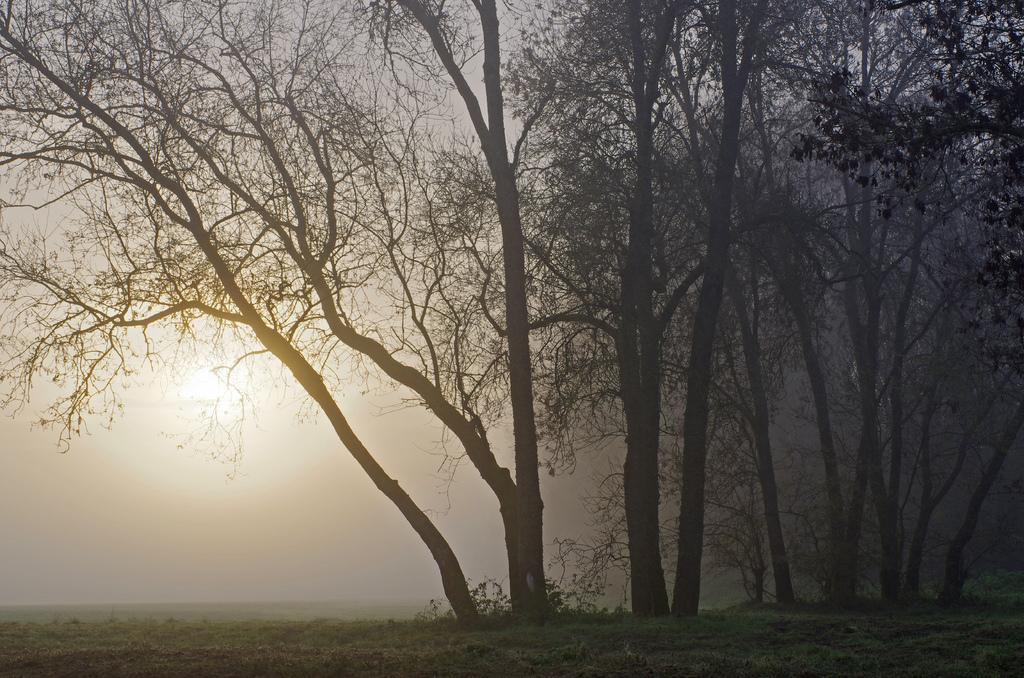Can you describe this image briefly? In this image I can see the ground, some grass on the ground, few trees which are black in color and in the background I can see the sky and the background. 